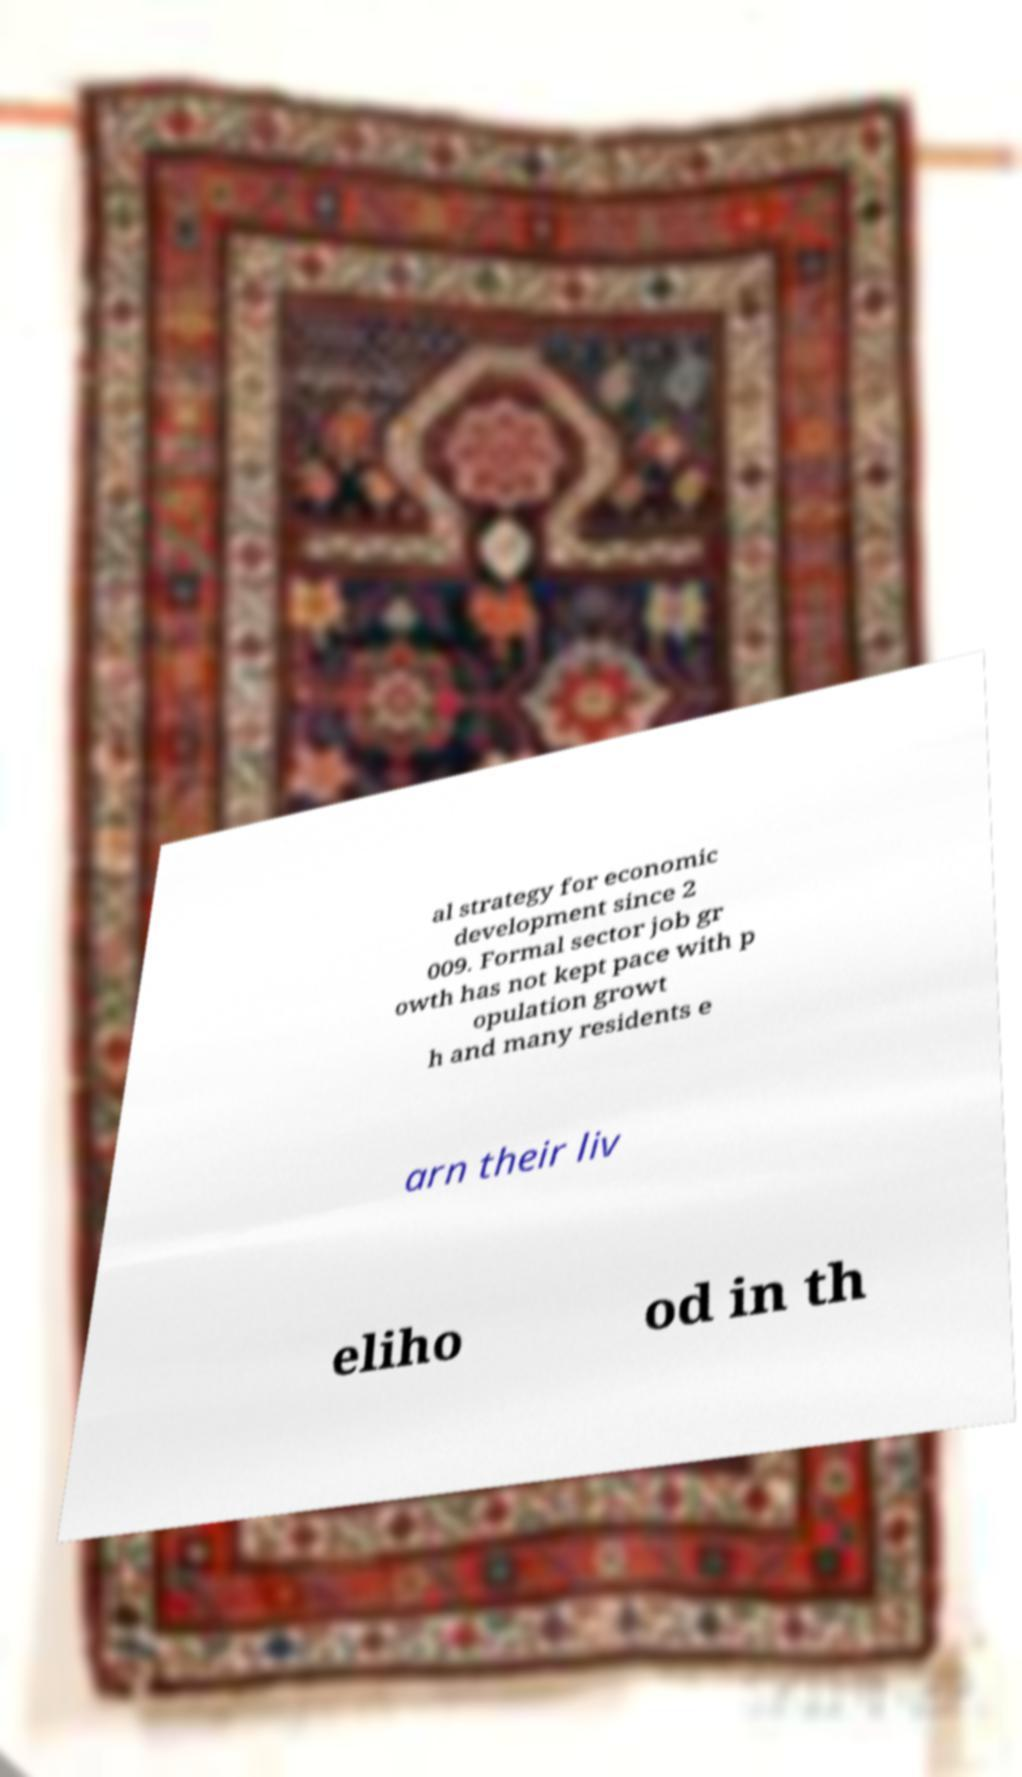Can you accurately transcribe the text from the provided image for me? al strategy for economic development since 2 009. Formal sector job gr owth has not kept pace with p opulation growt h and many residents e arn their liv eliho od in th 